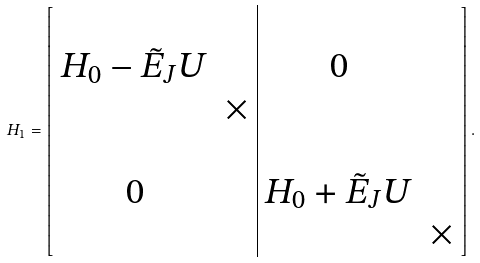<formula> <loc_0><loc_0><loc_500><loc_500>H _ { 1 } = \left [ \begin{array} { c c | c c } & & & \\ H _ { 0 } - \tilde { E } _ { J } U & & 0 & \\ & \times & & \\ & & & \\ 0 & & H _ { 0 } + \tilde { E } _ { J } U & \\ & & & \times \end{array} \right ] .</formula> 